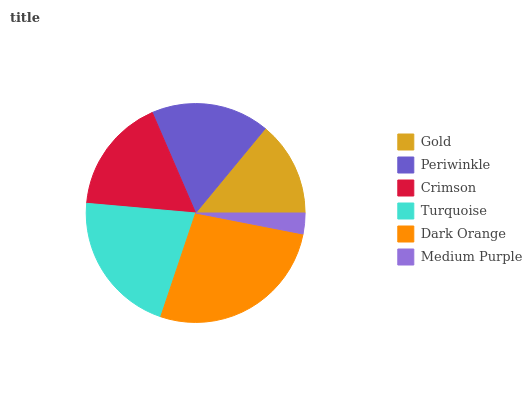Is Medium Purple the minimum?
Answer yes or no. Yes. Is Dark Orange the maximum?
Answer yes or no. Yes. Is Periwinkle the minimum?
Answer yes or no. No. Is Periwinkle the maximum?
Answer yes or no. No. Is Periwinkle greater than Gold?
Answer yes or no. Yes. Is Gold less than Periwinkle?
Answer yes or no. Yes. Is Gold greater than Periwinkle?
Answer yes or no. No. Is Periwinkle less than Gold?
Answer yes or no. No. Is Periwinkle the high median?
Answer yes or no. Yes. Is Crimson the low median?
Answer yes or no. Yes. Is Medium Purple the high median?
Answer yes or no. No. Is Medium Purple the low median?
Answer yes or no. No. 